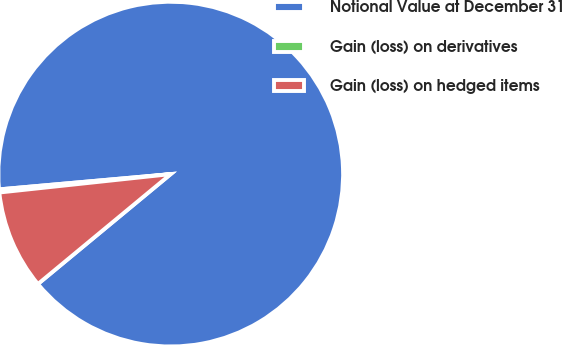<chart> <loc_0><loc_0><loc_500><loc_500><pie_chart><fcel>Notional Value at December 31<fcel>Gain (loss) on derivatives<fcel>Gain (loss) on hedged items<nl><fcel>90.41%<fcel>0.29%<fcel>9.3%<nl></chart> 